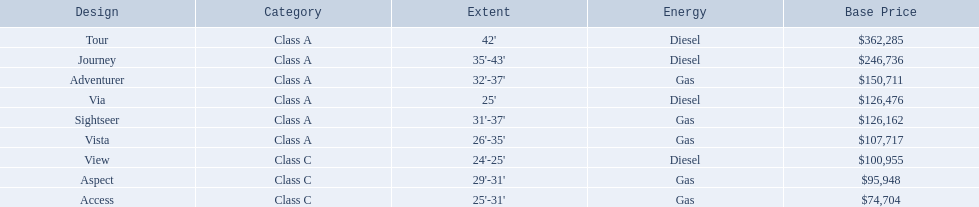Which models of winnebago are there? Tour, Journey, Adventurer, Via, Sightseer, Vista, View, Aspect, Access. Which ones are diesel? Tour, Journey, Sightseer, View. Which of those is the longest? Tour, Journey. Which one has the highest starting price? Tour. 